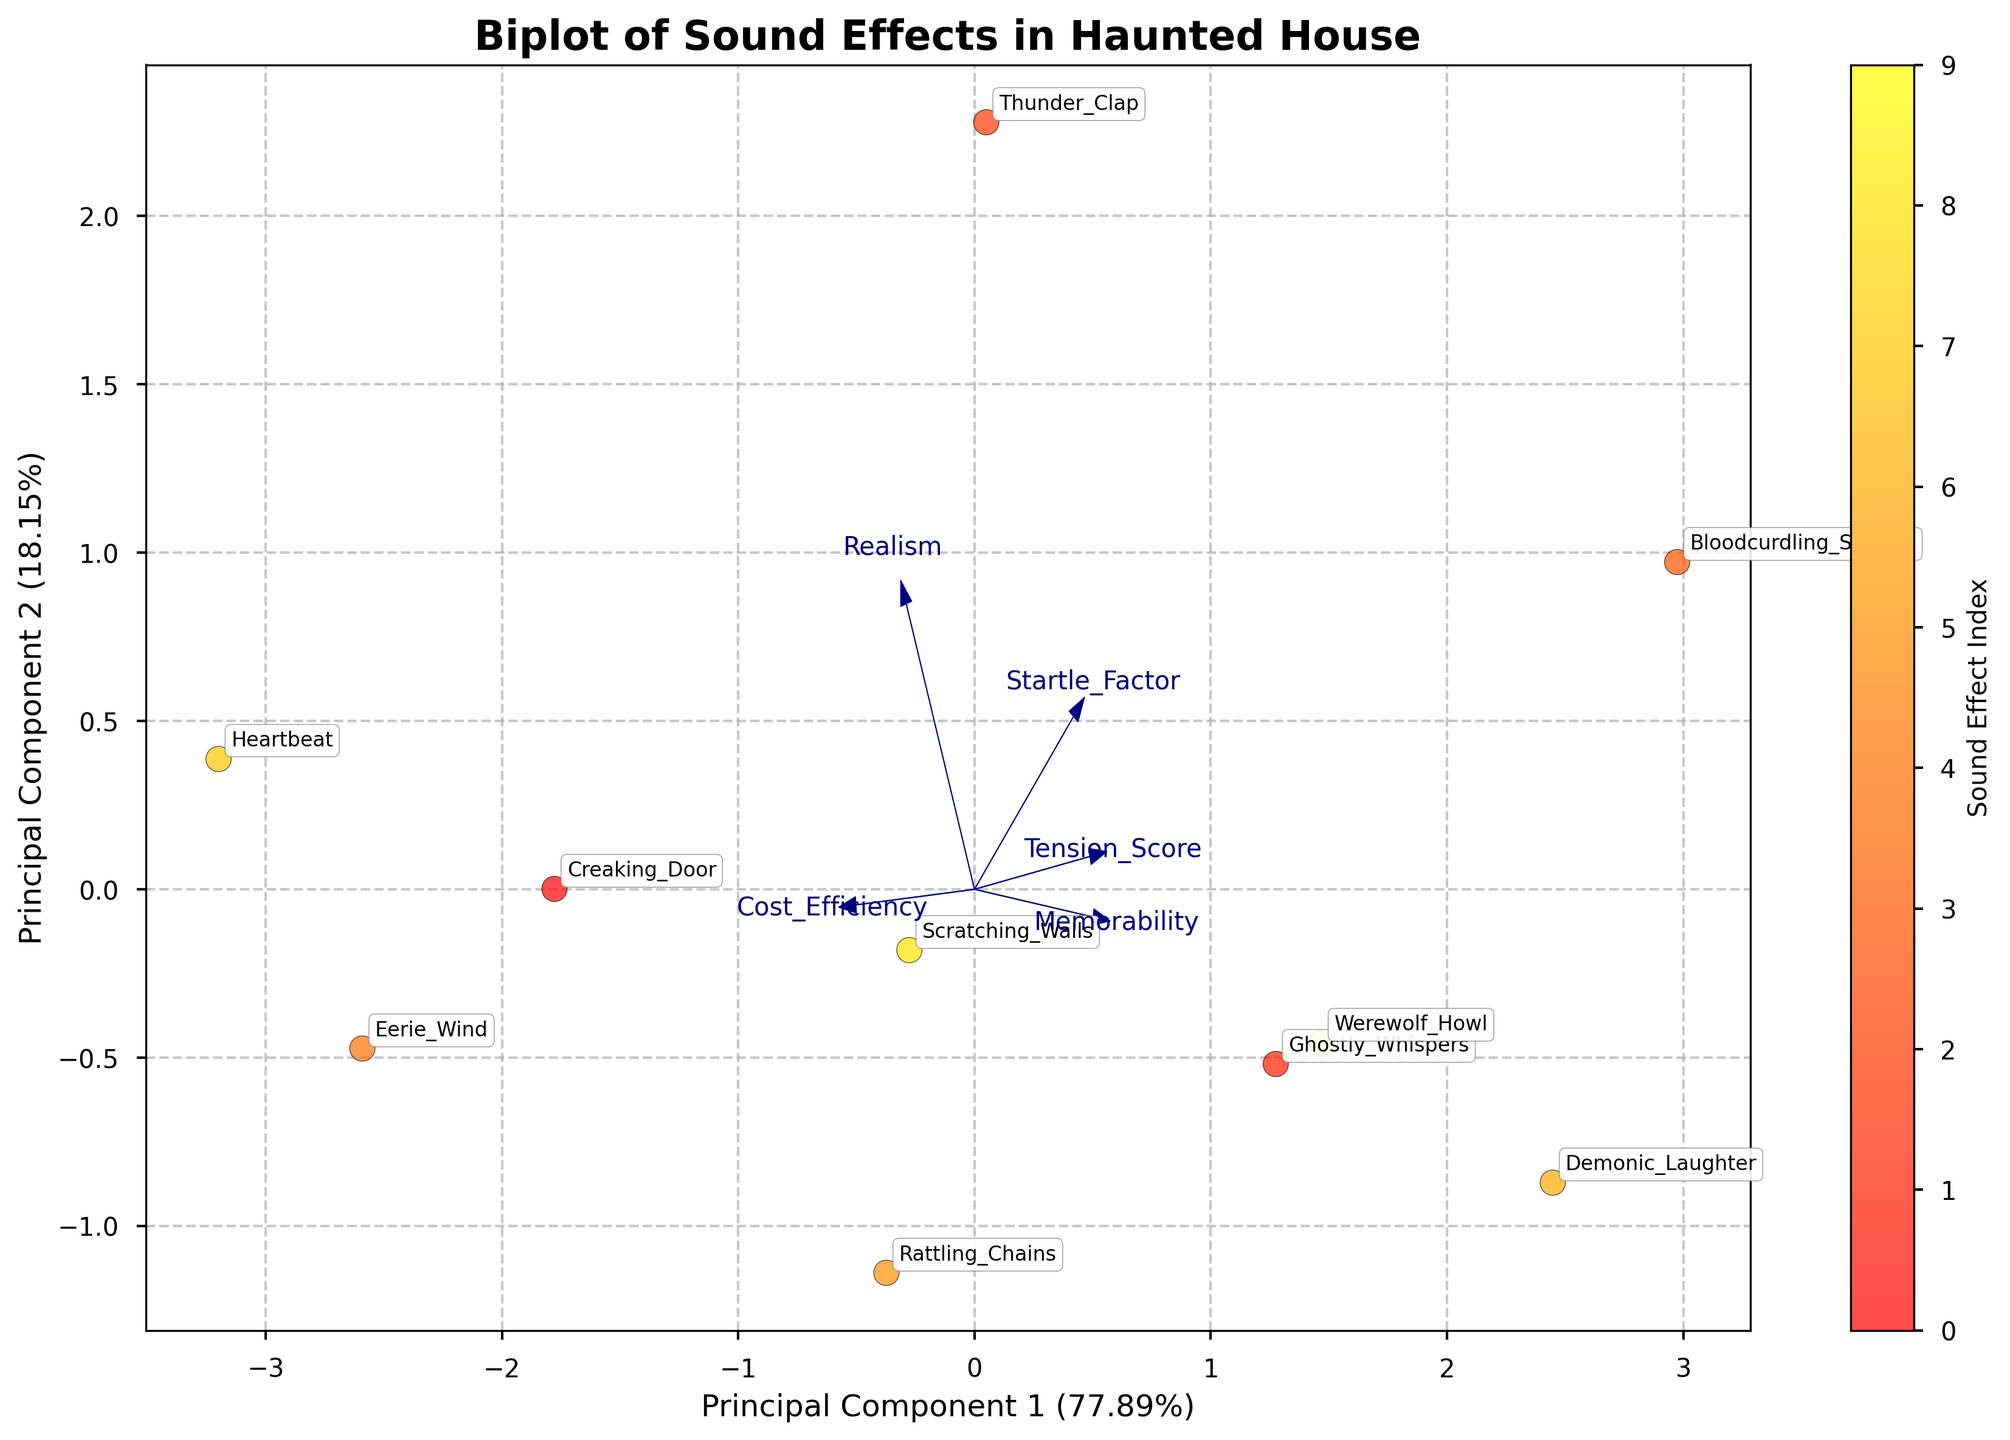What is the title of the biplot? The title of a biplot is typically prominently displayed at the top or near the top of the figure. For this specific biplot, the title is clearly stated.
Answer: Biplot of Sound Effects in Haunted House How many sound effects are represented in the biplot? To determine the number of sound effects, we can count the number of labeled data points on the plot. Each data point corresponds to a sound effect label.
Answer: 10 Which principal component explains more variance? By reading the x and y labels, we can see the explained variance percentage for each principal component. The component with the larger percentage explains more variance.
Answer: Principal Component 1 Which sound effect is labeled closest to the origin of the biplot? The origin is at (0, 0). Observe the plot and identify the sound effect label that is closest to this point.
Answer: Rattling_Chains Which sound effect has the highest Startle Factor based on its direction on the biplot? Startle Factor is represented by an arrow. The direction in which this arrow extends farthest from the origin will correspond to the sound effect with the highest value in this dimension.
Answer: Bloodcurdling_Scream Which two features have vectors that appear closest to each other on the biplot? By analyzing the direction of the vectors (arrows), we can see which two are most aligned or parallel, indicating they are closest.
Answer: Memorability and Demonic_Laughter How does 'Cost_Efficiency' align with the principal components? By observing the orientation and direction of the 'Cost_Efficiency' arrow relative to the principal components' axes, we can infer its alignment.
Answer: Along Principal Component 1 Which sound effect appears to be highest on Principal Component 2? Principal Component 2 is represented by the y-axis. The sound effect that is the highest on the y-axis (farthest above the origin) has the highest Principal Component 2 value.
Answer: Bloodcurdling_Scream Which two sound effects are the furthest apart on the biplot? By visually comparing the distances between the sound effect labels, we can determine which pair are furthest from each other.
Answer: Bloodcurdling_Scream and Creaking_Door What features are most strongly associated with Principal Component 1? PCA component vectors' lengths and directions indicate their association strength. Longer arrows pointing in the direction of Principal Component 1 show strong association.
Answer: Cost_Efficiency and Realism 